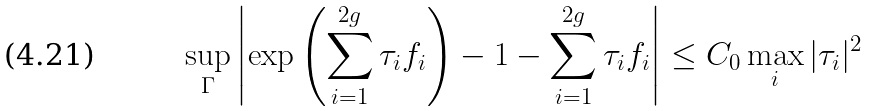<formula> <loc_0><loc_0><loc_500><loc_500>\sup _ { \Gamma } \left | \exp \left ( \sum _ { i = 1 } ^ { 2 g } \tau _ { i } f _ { i } \right ) - 1 - \sum _ { i = 1 } ^ { 2 g } \tau _ { i } f _ { i } \right | \leq C _ { 0 } \max _ { i } | \tau _ { i } | ^ { 2 }</formula> 